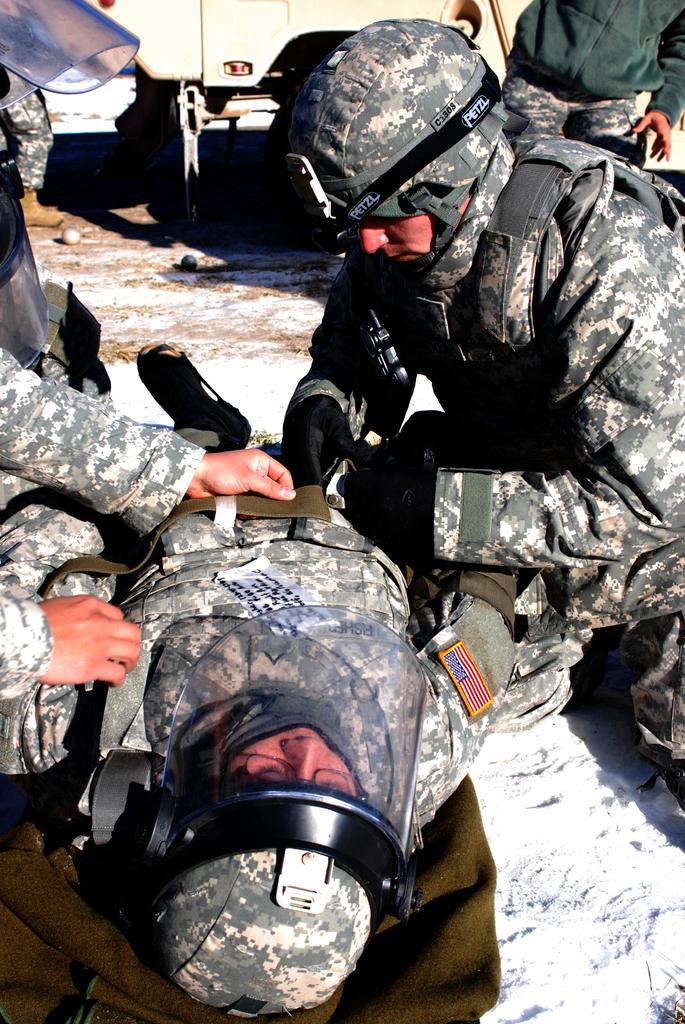How would you summarize this image in a sentence or two? In this picture, we can see a few soldiers among them a soldier is lying on the mat, we can see the ground with some objects like mat, balls, and we can see the ground is covered with snow, and we can see some object in the top side of the picture. 